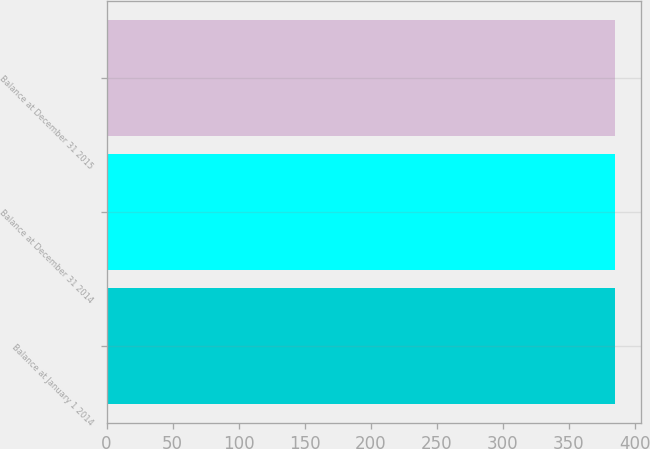<chart> <loc_0><loc_0><loc_500><loc_500><bar_chart><fcel>Balance at January 1 2014<fcel>Balance at December 31 2014<fcel>Balance at December 31 2015<nl><fcel>385<fcel>385.1<fcel>385.2<nl></chart> 